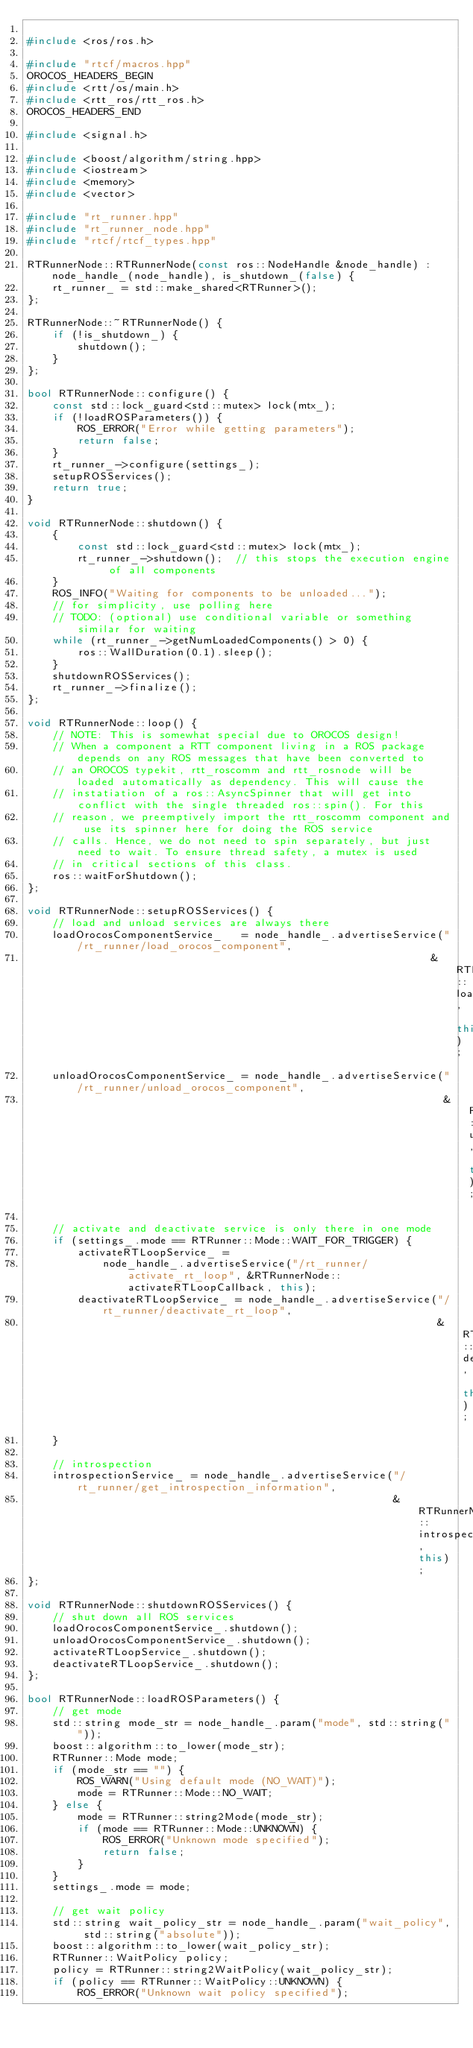<code> <loc_0><loc_0><loc_500><loc_500><_C++_>
#include <ros/ros.h>

#include "rtcf/macros.hpp"
OROCOS_HEADERS_BEGIN
#include <rtt/os/main.h>
#include <rtt_ros/rtt_ros.h>
OROCOS_HEADERS_END

#include <signal.h>

#include <boost/algorithm/string.hpp>
#include <iostream>
#include <memory>
#include <vector>

#include "rt_runner.hpp"
#include "rt_runner_node.hpp"
#include "rtcf/rtcf_types.hpp"

RTRunnerNode::RTRunnerNode(const ros::NodeHandle &node_handle) : node_handle_(node_handle), is_shutdown_(false) {
    rt_runner_ = std::make_shared<RTRunner>();
};

RTRunnerNode::~RTRunnerNode() {
    if (!is_shutdown_) {
        shutdown();
    }
};

bool RTRunnerNode::configure() {
    const std::lock_guard<std::mutex> lock(mtx_);
    if (!loadROSParameters()) {
        ROS_ERROR("Error while getting parameters");
        return false;
    }
    rt_runner_->configure(settings_);
    setupROSServices();
    return true;
}

void RTRunnerNode::shutdown() {
    {
        const std::lock_guard<std::mutex> lock(mtx_);
        rt_runner_->shutdown();  // this stops the execution engine of all components
    }
    ROS_INFO("Waiting for components to be unloaded...");
    // for simplicity, use polling here
    // TODO: (optional) use conditional variable or something similar for waiting
    while (rt_runner_->getNumLoadedComponents() > 0) {
        ros::WallDuration(0.1).sleep();
    }
    shutdownROSServices();
    rt_runner_->finalize();
};

void RTRunnerNode::loop() {
    // NOTE: This is somewhat special due to OROCOS design!
    // When a component a RTT component living in a ROS package depends on any ROS messages that have been converted to
    // an OROCOS typekit, rtt_roscomm and rtt_rosnode will be loaded automatically as dependency. This will cause the
    // instatiation of a ros::AsyncSpinner that will get into conflict with the single threaded ros::spin(). For this
    // reason, we preemptively import the rtt_roscomm component and use its spinner here for doing the ROS service
    // calls. Hence, we do not need to spin separately, but just need to wait. To ensure thread safety, a mutex is used
    // in critical sections of this class.
    ros::waitForShutdown();
};

void RTRunnerNode::setupROSServices() {
    // load and unload services are always there
    loadOrocosComponentService_   = node_handle_.advertiseService("/rt_runner/load_orocos_component",
                                                                &RTRunnerNode::loadOrocosComponentCallback, this);
    unloadOrocosComponentService_ = node_handle_.advertiseService("/rt_runner/unload_orocos_component",
                                                                  &RTRunnerNode::unloadOrocosComponentCallback, this);

    // activate and deactivate service is only there in one mode
    if (settings_.mode == RTRunner::Mode::WAIT_FOR_TRIGGER) {
        activateRTLoopService_ =
            node_handle_.advertiseService("/rt_runner/activate_rt_loop", &RTRunnerNode::activateRTLoopCallback, this);
        deactivateRTLoopService_ = node_handle_.advertiseService("/rt_runner/deactivate_rt_loop",
                                                                 &RTRunnerNode::deactivateRTLoopCallback, this);
    }

    // introspection
    introspectionService_ = node_handle_.advertiseService("/rt_runner/get_introspection_information",
                                                          &RTRunnerNode::introspectionCallback, this);
};

void RTRunnerNode::shutdownROSServices() {
    // shut down all ROS services
    loadOrocosComponentService_.shutdown();
    unloadOrocosComponentService_.shutdown();
    activateRTLoopService_.shutdown();
    deactivateRTLoopService_.shutdown();
};

bool RTRunnerNode::loadROSParameters() {
    // get mode
    std::string mode_str = node_handle_.param("mode", std::string(""));
    boost::algorithm::to_lower(mode_str);
    RTRunner::Mode mode;
    if (mode_str == "") {
        ROS_WARN("Using default mode (NO_WAIT)");
        mode = RTRunner::Mode::NO_WAIT;
    } else {
        mode = RTRunner::string2Mode(mode_str);
        if (mode == RTRunner::Mode::UNKNOWN) {
            ROS_ERROR("Unknown mode specified");
            return false;
        }
    }
    settings_.mode = mode;

    // get wait policy
    std::string wait_policy_str = node_handle_.param("wait_policy", std::string("absolute"));
    boost::algorithm::to_lower(wait_policy_str);
    RTRunner::WaitPolicy policy;
    policy = RTRunner::string2WaitPolicy(wait_policy_str);
    if (policy == RTRunner::WaitPolicy::UNKNOWN) {
        ROS_ERROR("Unknown wait policy specified");</code> 